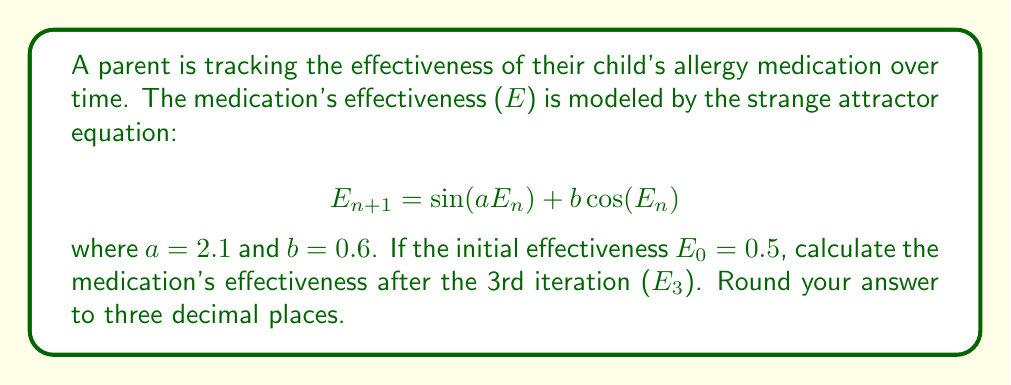Can you solve this math problem? To solve this problem, we need to iterate the given equation three times:

Step 1: Calculate $E_1$
$$E_1 = \sin(2.1 \cdot 0.5) + 0.6\cos(0.5)$$
$$E_1 = \sin(1.05) + 0.6\cos(0.5)$$
$$E_1 \approx 0.8775 + 0.5160$$
$$E_1 \approx 1.3935$$

Step 2: Calculate $E_2$
$$E_2 = \sin(2.1 \cdot 1.3935) + 0.6\cos(1.3935)$$
$$E_2 = \sin(2.9264) + 0.6\cos(1.3935)$$
$$E_2 \approx 0.2384 + 0.1137$$
$$E_2 \approx 0.3521$$

Step 3: Calculate $E_3$
$$E_3 = \sin(2.1 \cdot 0.3521) + 0.6\cos(0.3521)$$
$$E_3 = \sin(0.7394) + 0.6\cos(0.3521)$$
$$E_3 \approx 0.6743 + 0.5549$$
$$E_3 \approx 1.2292$$

Rounding to three decimal places: $E_3 \approx 1.229$
Answer: 1.229 